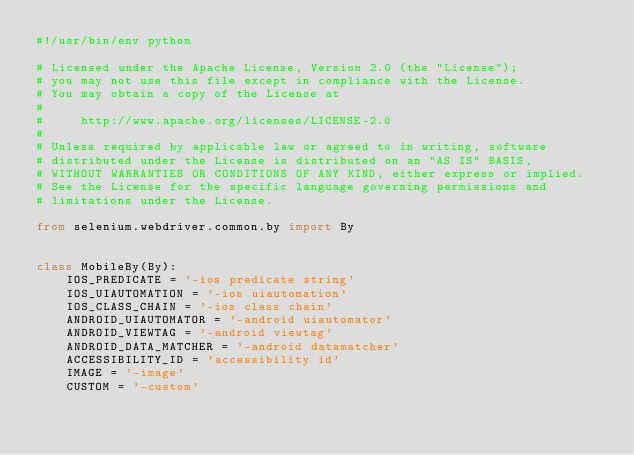<code> <loc_0><loc_0><loc_500><loc_500><_Python_>#!/usr/bin/env python

# Licensed under the Apache License, Version 2.0 (the "License");
# you may not use this file except in compliance with the License.
# You may obtain a copy of the License at
#
#     http://www.apache.org/licenses/LICENSE-2.0
#
# Unless required by applicable law or agreed to in writing, software
# distributed under the License is distributed on an "AS IS" BASIS,
# WITHOUT WARRANTIES OR CONDITIONS OF ANY KIND, either express or implied.
# See the License for the specific language governing permissions and
# limitations under the License.

from selenium.webdriver.common.by import By


class MobileBy(By):
    IOS_PREDICATE = '-ios predicate string'
    IOS_UIAUTOMATION = '-ios uiautomation'
    IOS_CLASS_CHAIN = '-ios class chain'
    ANDROID_UIAUTOMATOR = '-android uiautomator'
    ANDROID_VIEWTAG = '-android viewtag'
    ANDROID_DATA_MATCHER = '-android datamatcher'
    ACCESSIBILITY_ID = 'accessibility id'
    IMAGE = '-image'
    CUSTOM = '-custom'
</code> 